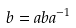Convert formula to latex. <formula><loc_0><loc_0><loc_500><loc_500>b = a b a ^ { - 1 }</formula> 